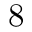<formula> <loc_0><loc_0><loc_500><loc_500>8</formula> 